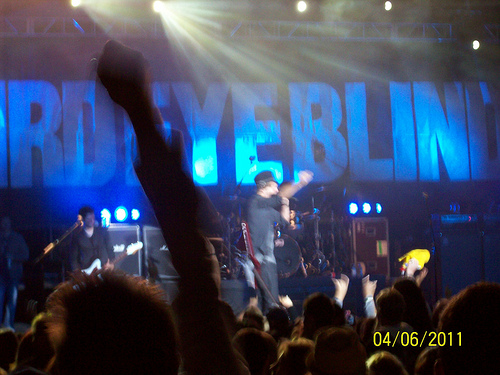<image>
Is the man to the left of the man? Yes. From this viewpoint, the man is positioned to the left side relative to the man. Where is the person in relation to the man? Is it next to the man? No. The person is not positioned next to the man. They are located in different areas of the scene. 